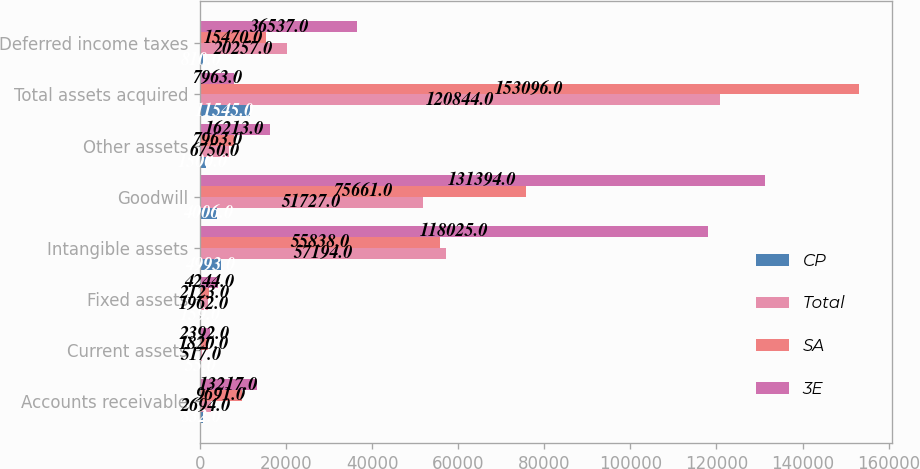Convert chart to OTSL. <chart><loc_0><loc_0><loc_500><loc_500><stacked_bar_chart><ecel><fcel>Accounts receivable<fcel>Current assets<fcel>Fixed assets<fcel>Intangible assets<fcel>Goodwill<fcel>Other assets<fcel>Total assets acquired<fcel>Deferred income taxes<nl><fcel>CP<fcel>832<fcel>55<fcel>159<fcel>4993<fcel>4006<fcel>1500<fcel>11545<fcel>810<nl><fcel>Total<fcel>2694<fcel>517<fcel>1962<fcel>57194<fcel>51727<fcel>6750<fcel>120844<fcel>20257<nl><fcel>SA<fcel>9691<fcel>1820<fcel>2123<fcel>55838<fcel>75661<fcel>7963<fcel>153096<fcel>15470<nl><fcel>3E<fcel>13217<fcel>2392<fcel>4244<fcel>118025<fcel>131394<fcel>16213<fcel>7963<fcel>36537<nl></chart> 